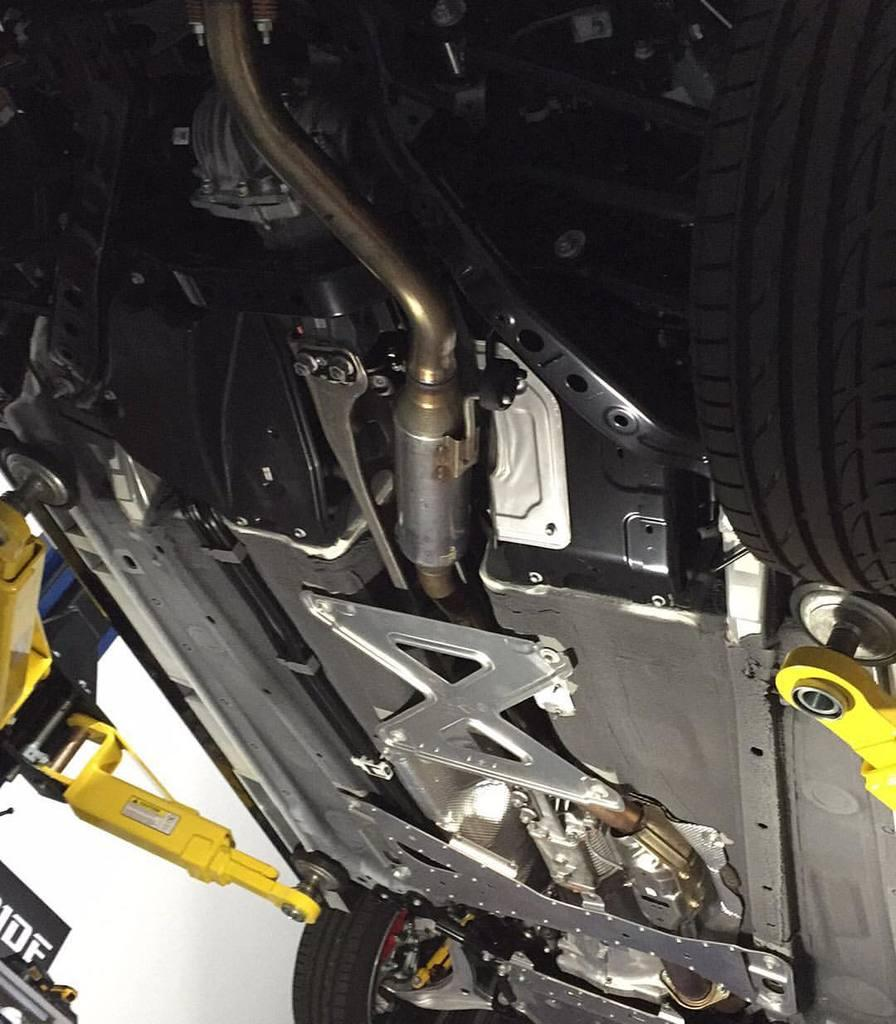What is the perspective of the image? The image shows a bottom view of a car. What part of the car is visible from this perspective? From this perspective, the undercarriage and tires of the car are visible. Can you describe the tires in the image? The tires appear to be in contact with the ground, and there may be some dirt or debris visible on them. What type of ice can be seen melting on the brake pads in the image? There is no ice or brake pads visible in the image; it shows a bottom view of a car with a focus on the undercarriage and tires. 